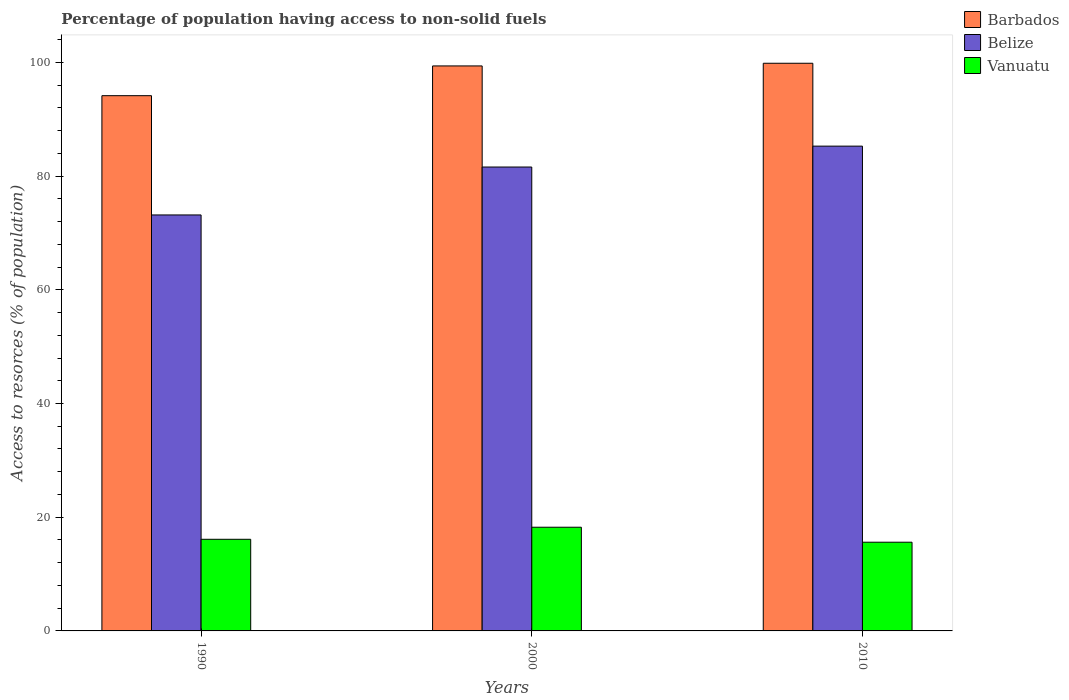Are the number of bars per tick equal to the number of legend labels?
Ensure brevity in your answer.  Yes. Are the number of bars on each tick of the X-axis equal?
Make the answer very short. Yes. How many bars are there on the 2nd tick from the left?
Offer a terse response. 3. What is the percentage of population having access to non-solid fuels in Vanuatu in 2000?
Offer a very short reply. 18.24. Across all years, what is the maximum percentage of population having access to non-solid fuels in Belize?
Keep it short and to the point. 85.27. Across all years, what is the minimum percentage of population having access to non-solid fuels in Barbados?
Provide a short and direct response. 94.14. In which year was the percentage of population having access to non-solid fuels in Barbados maximum?
Your answer should be compact. 2010. What is the total percentage of population having access to non-solid fuels in Belize in the graph?
Your answer should be very brief. 240.03. What is the difference between the percentage of population having access to non-solid fuels in Belize in 1990 and that in 2000?
Your answer should be very brief. -8.43. What is the difference between the percentage of population having access to non-solid fuels in Barbados in 2000 and the percentage of population having access to non-solid fuels in Vanuatu in 2010?
Offer a very short reply. 83.77. What is the average percentage of population having access to non-solid fuels in Barbados per year?
Offer a terse response. 97.79. In the year 2010, what is the difference between the percentage of population having access to non-solid fuels in Vanuatu and percentage of population having access to non-solid fuels in Barbados?
Your answer should be compact. -84.24. What is the ratio of the percentage of population having access to non-solid fuels in Vanuatu in 2000 to that in 2010?
Your answer should be very brief. 1.17. Is the percentage of population having access to non-solid fuels in Vanuatu in 1990 less than that in 2000?
Provide a succinct answer. Yes. What is the difference between the highest and the second highest percentage of population having access to non-solid fuels in Barbados?
Give a very brief answer. 0.47. What is the difference between the highest and the lowest percentage of population having access to non-solid fuels in Vanuatu?
Your answer should be compact. 2.63. Is the sum of the percentage of population having access to non-solid fuels in Barbados in 2000 and 2010 greater than the maximum percentage of population having access to non-solid fuels in Vanuatu across all years?
Provide a short and direct response. Yes. What does the 3rd bar from the left in 2000 represents?
Provide a succinct answer. Vanuatu. What does the 3rd bar from the right in 2010 represents?
Your response must be concise. Barbados. How many bars are there?
Provide a short and direct response. 9. Are all the bars in the graph horizontal?
Provide a short and direct response. No. How many years are there in the graph?
Ensure brevity in your answer.  3. Are the values on the major ticks of Y-axis written in scientific E-notation?
Your answer should be compact. No. Does the graph contain grids?
Your response must be concise. No. How are the legend labels stacked?
Ensure brevity in your answer.  Vertical. What is the title of the graph?
Ensure brevity in your answer.  Percentage of population having access to non-solid fuels. Does "St. Kitts and Nevis" appear as one of the legend labels in the graph?
Your answer should be very brief. No. What is the label or title of the X-axis?
Offer a terse response. Years. What is the label or title of the Y-axis?
Ensure brevity in your answer.  Access to resorces (% of population). What is the Access to resorces (% of population) of Barbados in 1990?
Offer a very short reply. 94.14. What is the Access to resorces (% of population) of Belize in 1990?
Your answer should be compact. 73.17. What is the Access to resorces (% of population) in Vanuatu in 1990?
Your answer should be very brief. 16.12. What is the Access to resorces (% of population) of Barbados in 2000?
Offer a terse response. 99.38. What is the Access to resorces (% of population) in Belize in 2000?
Ensure brevity in your answer.  81.6. What is the Access to resorces (% of population) in Vanuatu in 2000?
Your response must be concise. 18.24. What is the Access to resorces (% of population) in Barbados in 2010?
Your answer should be very brief. 99.85. What is the Access to resorces (% of population) in Belize in 2010?
Make the answer very short. 85.27. What is the Access to resorces (% of population) of Vanuatu in 2010?
Ensure brevity in your answer.  15.6. Across all years, what is the maximum Access to resorces (% of population) of Barbados?
Offer a very short reply. 99.85. Across all years, what is the maximum Access to resorces (% of population) of Belize?
Offer a very short reply. 85.27. Across all years, what is the maximum Access to resorces (% of population) in Vanuatu?
Keep it short and to the point. 18.24. Across all years, what is the minimum Access to resorces (% of population) of Barbados?
Offer a terse response. 94.14. Across all years, what is the minimum Access to resorces (% of population) of Belize?
Your response must be concise. 73.17. Across all years, what is the minimum Access to resorces (% of population) in Vanuatu?
Ensure brevity in your answer.  15.6. What is the total Access to resorces (% of population) in Barbados in the graph?
Your answer should be very brief. 293.37. What is the total Access to resorces (% of population) in Belize in the graph?
Ensure brevity in your answer.  240.03. What is the total Access to resorces (% of population) in Vanuatu in the graph?
Make the answer very short. 49.96. What is the difference between the Access to resorces (% of population) of Barbados in 1990 and that in 2000?
Offer a terse response. -5.23. What is the difference between the Access to resorces (% of population) in Belize in 1990 and that in 2000?
Keep it short and to the point. -8.43. What is the difference between the Access to resorces (% of population) of Vanuatu in 1990 and that in 2000?
Provide a succinct answer. -2.12. What is the difference between the Access to resorces (% of population) in Barbados in 1990 and that in 2010?
Keep it short and to the point. -5.7. What is the difference between the Access to resorces (% of population) in Belize in 1990 and that in 2010?
Ensure brevity in your answer.  -12.1. What is the difference between the Access to resorces (% of population) in Vanuatu in 1990 and that in 2010?
Provide a succinct answer. 0.51. What is the difference between the Access to resorces (% of population) of Barbados in 2000 and that in 2010?
Make the answer very short. -0.47. What is the difference between the Access to resorces (% of population) of Belize in 2000 and that in 2010?
Provide a short and direct response. -3.67. What is the difference between the Access to resorces (% of population) in Vanuatu in 2000 and that in 2010?
Make the answer very short. 2.63. What is the difference between the Access to resorces (% of population) of Barbados in 1990 and the Access to resorces (% of population) of Belize in 2000?
Your answer should be very brief. 12.55. What is the difference between the Access to resorces (% of population) of Barbados in 1990 and the Access to resorces (% of population) of Vanuatu in 2000?
Provide a short and direct response. 75.91. What is the difference between the Access to resorces (% of population) in Belize in 1990 and the Access to resorces (% of population) in Vanuatu in 2000?
Ensure brevity in your answer.  54.93. What is the difference between the Access to resorces (% of population) in Barbados in 1990 and the Access to resorces (% of population) in Belize in 2010?
Your response must be concise. 8.87. What is the difference between the Access to resorces (% of population) in Barbados in 1990 and the Access to resorces (% of population) in Vanuatu in 2010?
Give a very brief answer. 78.54. What is the difference between the Access to resorces (% of population) in Belize in 1990 and the Access to resorces (% of population) in Vanuatu in 2010?
Keep it short and to the point. 57.56. What is the difference between the Access to resorces (% of population) of Barbados in 2000 and the Access to resorces (% of population) of Belize in 2010?
Offer a terse response. 14.11. What is the difference between the Access to resorces (% of population) of Barbados in 2000 and the Access to resorces (% of population) of Vanuatu in 2010?
Your answer should be compact. 83.77. What is the difference between the Access to resorces (% of population) in Belize in 2000 and the Access to resorces (% of population) in Vanuatu in 2010?
Provide a short and direct response. 65.99. What is the average Access to resorces (% of population) in Barbados per year?
Your answer should be compact. 97.79. What is the average Access to resorces (% of population) in Belize per year?
Your answer should be very brief. 80.01. What is the average Access to resorces (% of population) in Vanuatu per year?
Your response must be concise. 16.65. In the year 1990, what is the difference between the Access to resorces (% of population) in Barbados and Access to resorces (% of population) in Belize?
Your response must be concise. 20.98. In the year 1990, what is the difference between the Access to resorces (% of population) of Barbados and Access to resorces (% of population) of Vanuatu?
Give a very brief answer. 78.03. In the year 1990, what is the difference between the Access to resorces (% of population) in Belize and Access to resorces (% of population) in Vanuatu?
Your answer should be compact. 57.05. In the year 2000, what is the difference between the Access to resorces (% of population) of Barbados and Access to resorces (% of population) of Belize?
Keep it short and to the point. 17.78. In the year 2000, what is the difference between the Access to resorces (% of population) in Barbados and Access to resorces (% of population) in Vanuatu?
Keep it short and to the point. 81.14. In the year 2000, what is the difference between the Access to resorces (% of population) of Belize and Access to resorces (% of population) of Vanuatu?
Provide a succinct answer. 63.36. In the year 2010, what is the difference between the Access to resorces (% of population) of Barbados and Access to resorces (% of population) of Belize?
Offer a terse response. 14.58. In the year 2010, what is the difference between the Access to resorces (% of population) in Barbados and Access to resorces (% of population) in Vanuatu?
Offer a very short reply. 84.24. In the year 2010, what is the difference between the Access to resorces (% of population) of Belize and Access to resorces (% of population) of Vanuatu?
Your answer should be compact. 69.67. What is the ratio of the Access to resorces (% of population) in Barbados in 1990 to that in 2000?
Ensure brevity in your answer.  0.95. What is the ratio of the Access to resorces (% of population) in Belize in 1990 to that in 2000?
Ensure brevity in your answer.  0.9. What is the ratio of the Access to resorces (% of population) in Vanuatu in 1990 to that in 2000?
Your response must be concise. 0.88. What is the ratio of the Access to resorces (% of population) in Barbados in 1990 to that in 2010?
Your answer should be compact. 0.94. What is the ratio of the Access to resorces (% of population) in Belize in 1990 to that in 2010?
Offer a terse response. 0.86. What is the ratio of the Access to resorces (% of population) in Vanuatu in 1990 to that in 2010?
Your answer should be very brief. 1.03. What is the ratio of the Access to resorces (% of population) of Barbados in 2000 to that in 2010?
Provide a succinct answer. 1. What is the ratio of the Access to resorces (% of population) of Belize in 2000 to that in 2010?
Ensure brevity in your answer.  0.96. What is the ratio of the Access to resorces (% of population) in Vanuatu in 2000 to that in 2010?
Your answer should be compact. 1.17. What is the difference between the highest and the second highest Access to resorces (% of population) in Barbados?
Provide a succinct answer. 0.47. What is the difference between the highest and the second highest Access to resorces (% of population) of Belize?
Your answer should be very brief. 3.67. What is the difference between the highest and the second highest Access to resorces (% of population) of Vanuatu?
Ensure brevity in your answer.  2.12. What is the difference between the highest and the lowest Access to resorces (% of population) in Barbados?
Your response must be concise. 5.7. What is the difference between the highest and the lowest Access to resorces (% of population) of Belize?
Provide a short and direct response. 12.1. What is the difference between the highest and the lowest Access to resorces (% of population) in Vanuatu?
Your response must be concise. 2.63. 